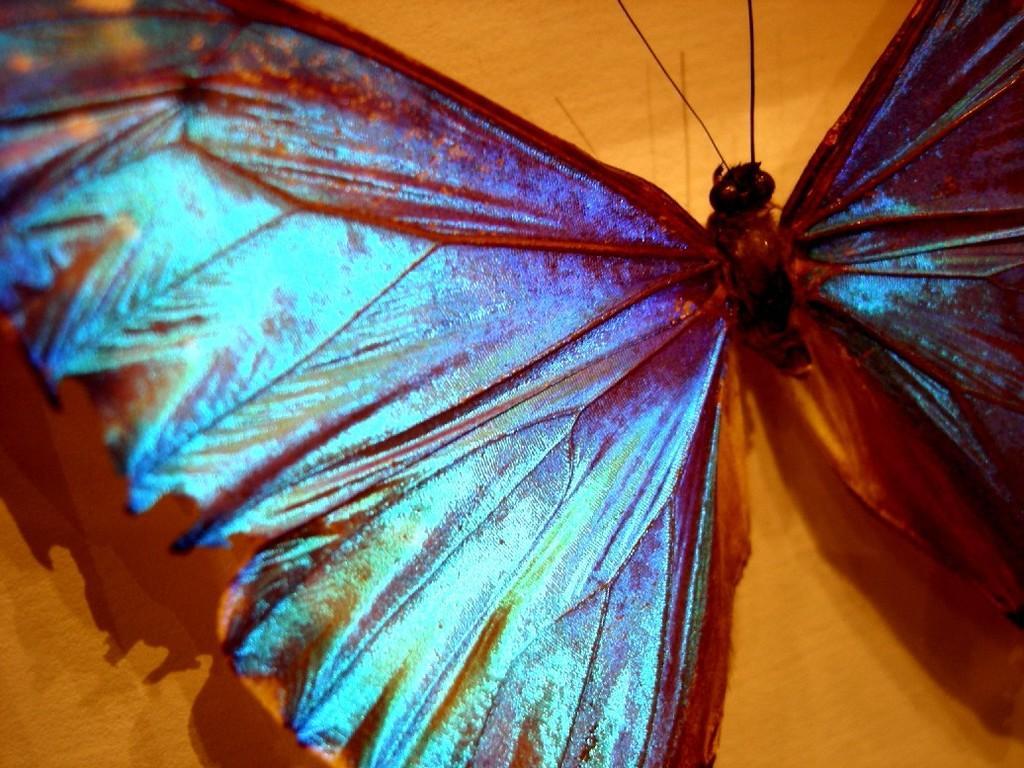Describe this image in one or two sentences. In this picture we can see an insect. In the background of the image it is brown. 